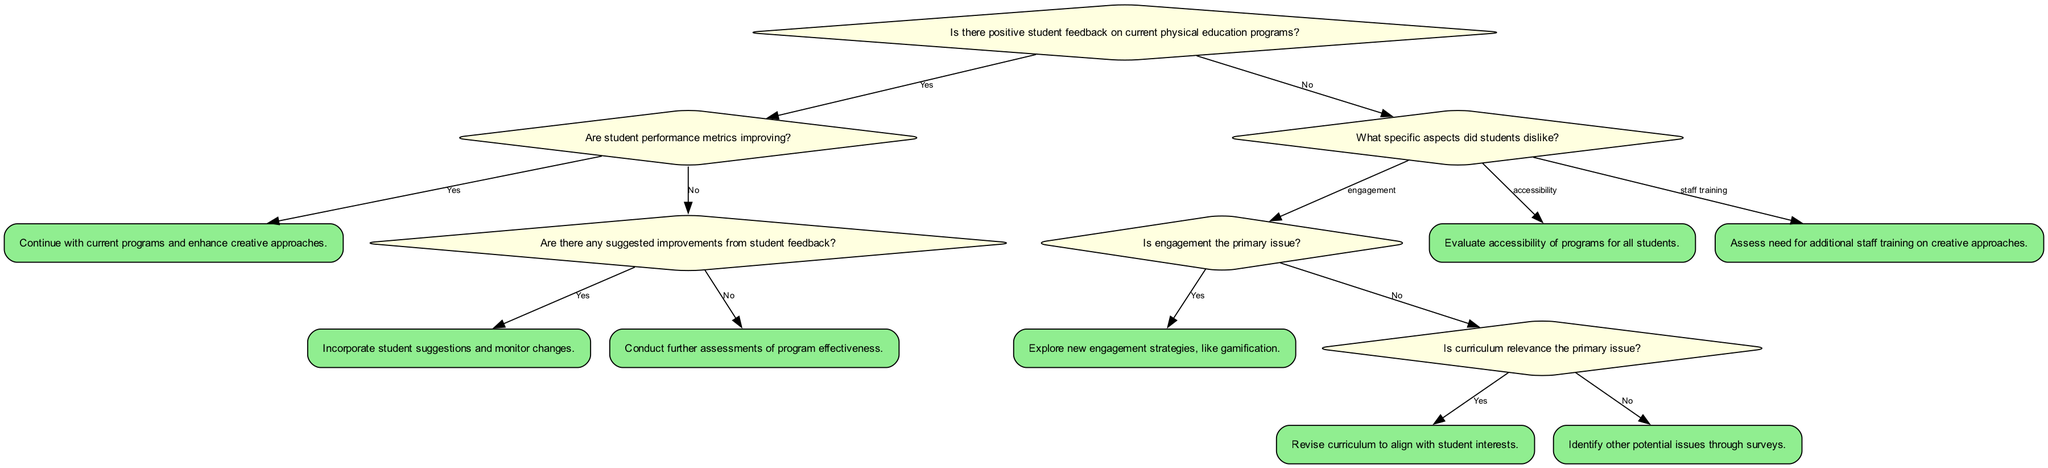What is the first question in the decision tree? The first question in the decision tree is located at the root, which asks if there is positive student feedback on current physical education programs. This is the starting point of the decision-making process.
Answer: Is there positive student feedback on current physical education programs? How many actions are listed in the decision tree? To find the number of actions, we can count the actions mentioned in the decision branches. There are five distinct actions: "Continue with current programs and enhance creative approaches," "Incorporate student suggestions and monitor changes," "Conduct further assessments of program effectiveness," "Explore new engagement strategies, like gamification," and "Revise curriculum to align with student interests."
Answer: 5 What happens if student performance metrics are not improving but there are suggested improvements? If student performance metrics are not improving, the decision tree checks if there are suggested improvements from student feedback. If there are, the action is to incorporate student suggestions and monitor changes, following the path from the "no" of performance metrics.
Answer: Incorporate student suggestions and monitor changes If students dislike engagement, what is the next question asked? If engagement is the aspect students dislike, the next question asked is whether engagement is the primary issue. This follows the "no" path from the first question about positive feedback and leads to a deeper assessment of concerns.
Answer: Is engagement the primary issue? What action is taken if there is no positive feedback and engagement is not the primary issue? If there is no positive feedback and engagement is not identified as the primary issue, the action taken is to identify other potential issues through surveys. This follows the evaluation of both engagement and curriculum relevance.
Answer: Identify other potential issues through surveys What specific aspect is evaluated if students cite accessibility as a concern? If students report accessibility as a concern, the evaluation focuses on the accessibility of programs for all students. This directs the decision-making process toward catering to the needs of every student regarding program inclusion.
Answer: Evaluate accessibility of programs for all students What is the action taken if students express dissatisfaction with staff training? The decision tree directs that if students express dissatisfaction with staff training, the action is to assess the need for additional staff training on creative approaches. This addresses the gap in training necessary for effective program implementation.
Answer: Assess need for additional staff training on creative approaches 